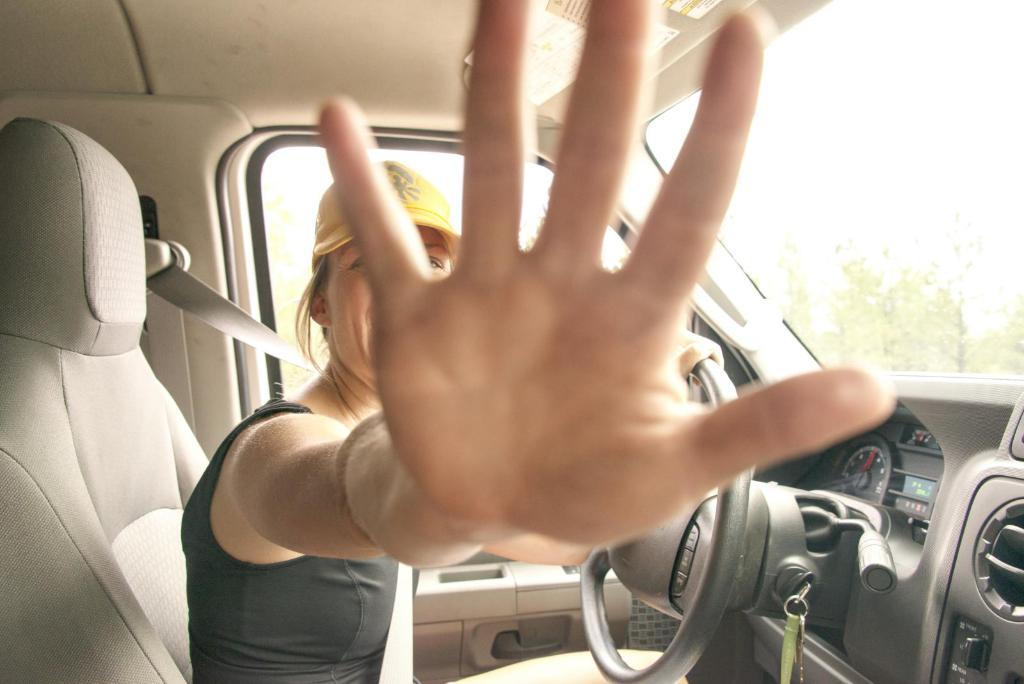Who is present in the image? There is a woman in the image. What is the woman doing in the image? The woman is sitting in a car. What can be seen in the background of the image? There are trees in the background of the image. What type of building can be seen in the image? There is no building present in the image; it features a woman sitting in a car with trees in the background. Can you tell me how many horses are visible in the image? There are no horses present in the image. 